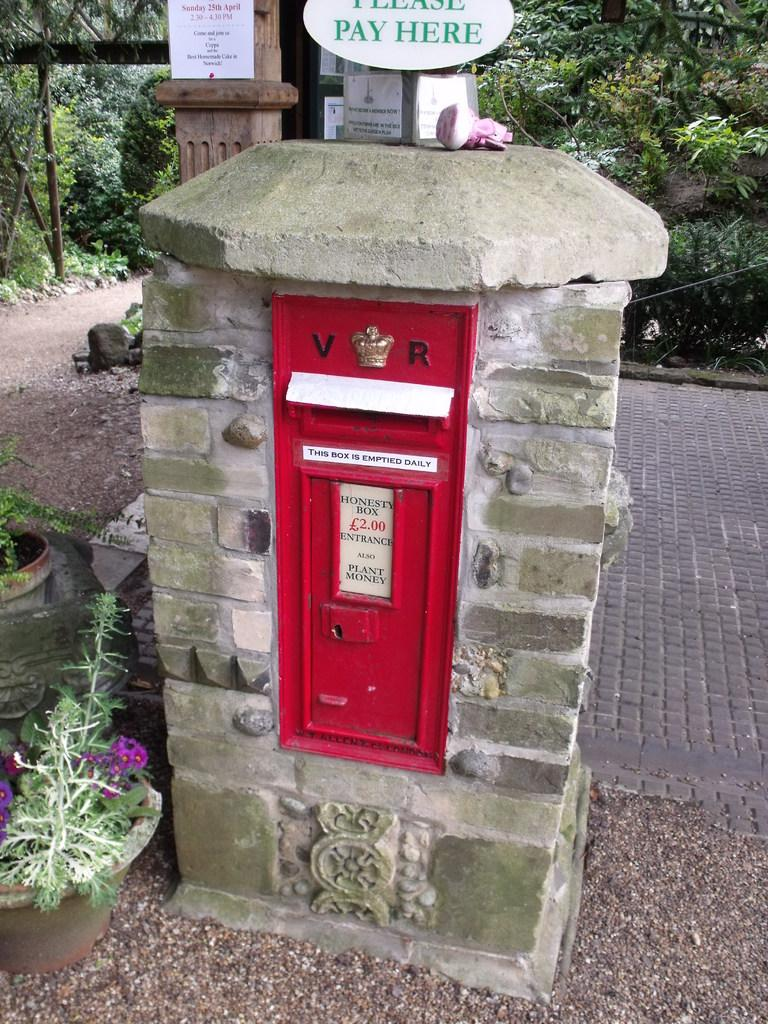What is located in the foreground of the image? There is a pillar, a box, and houseplants in the foreground of the image. What can be seen in the background of the image? There are trees, a board, and metal rods in the background of the image. What might suggest that the image was taken during the day? The presence of natural light and shadows in the image suggests that it was likely taken during the day. What type of committee is meeting in the image? There is no committee present in the image; it features a pillar, a box, houseplants, trees, a board, and metal rods. Can you tell me how many dogs are visible in the image? There are no dogs present in the image. 